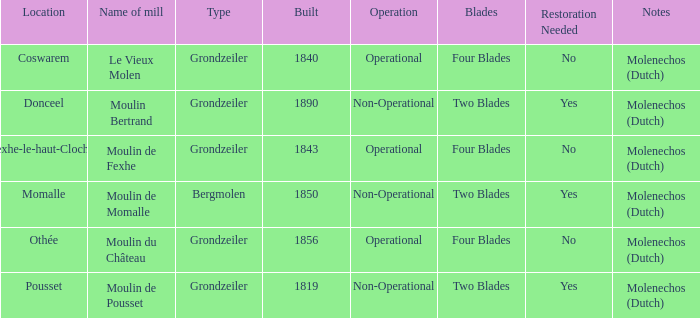What is the Name of the Grondzeiler Mill? Le Vieux Molen, Moulin Bertrand, Moulin de Fexhe, Moulin du Château, Moulin de Pousset. 